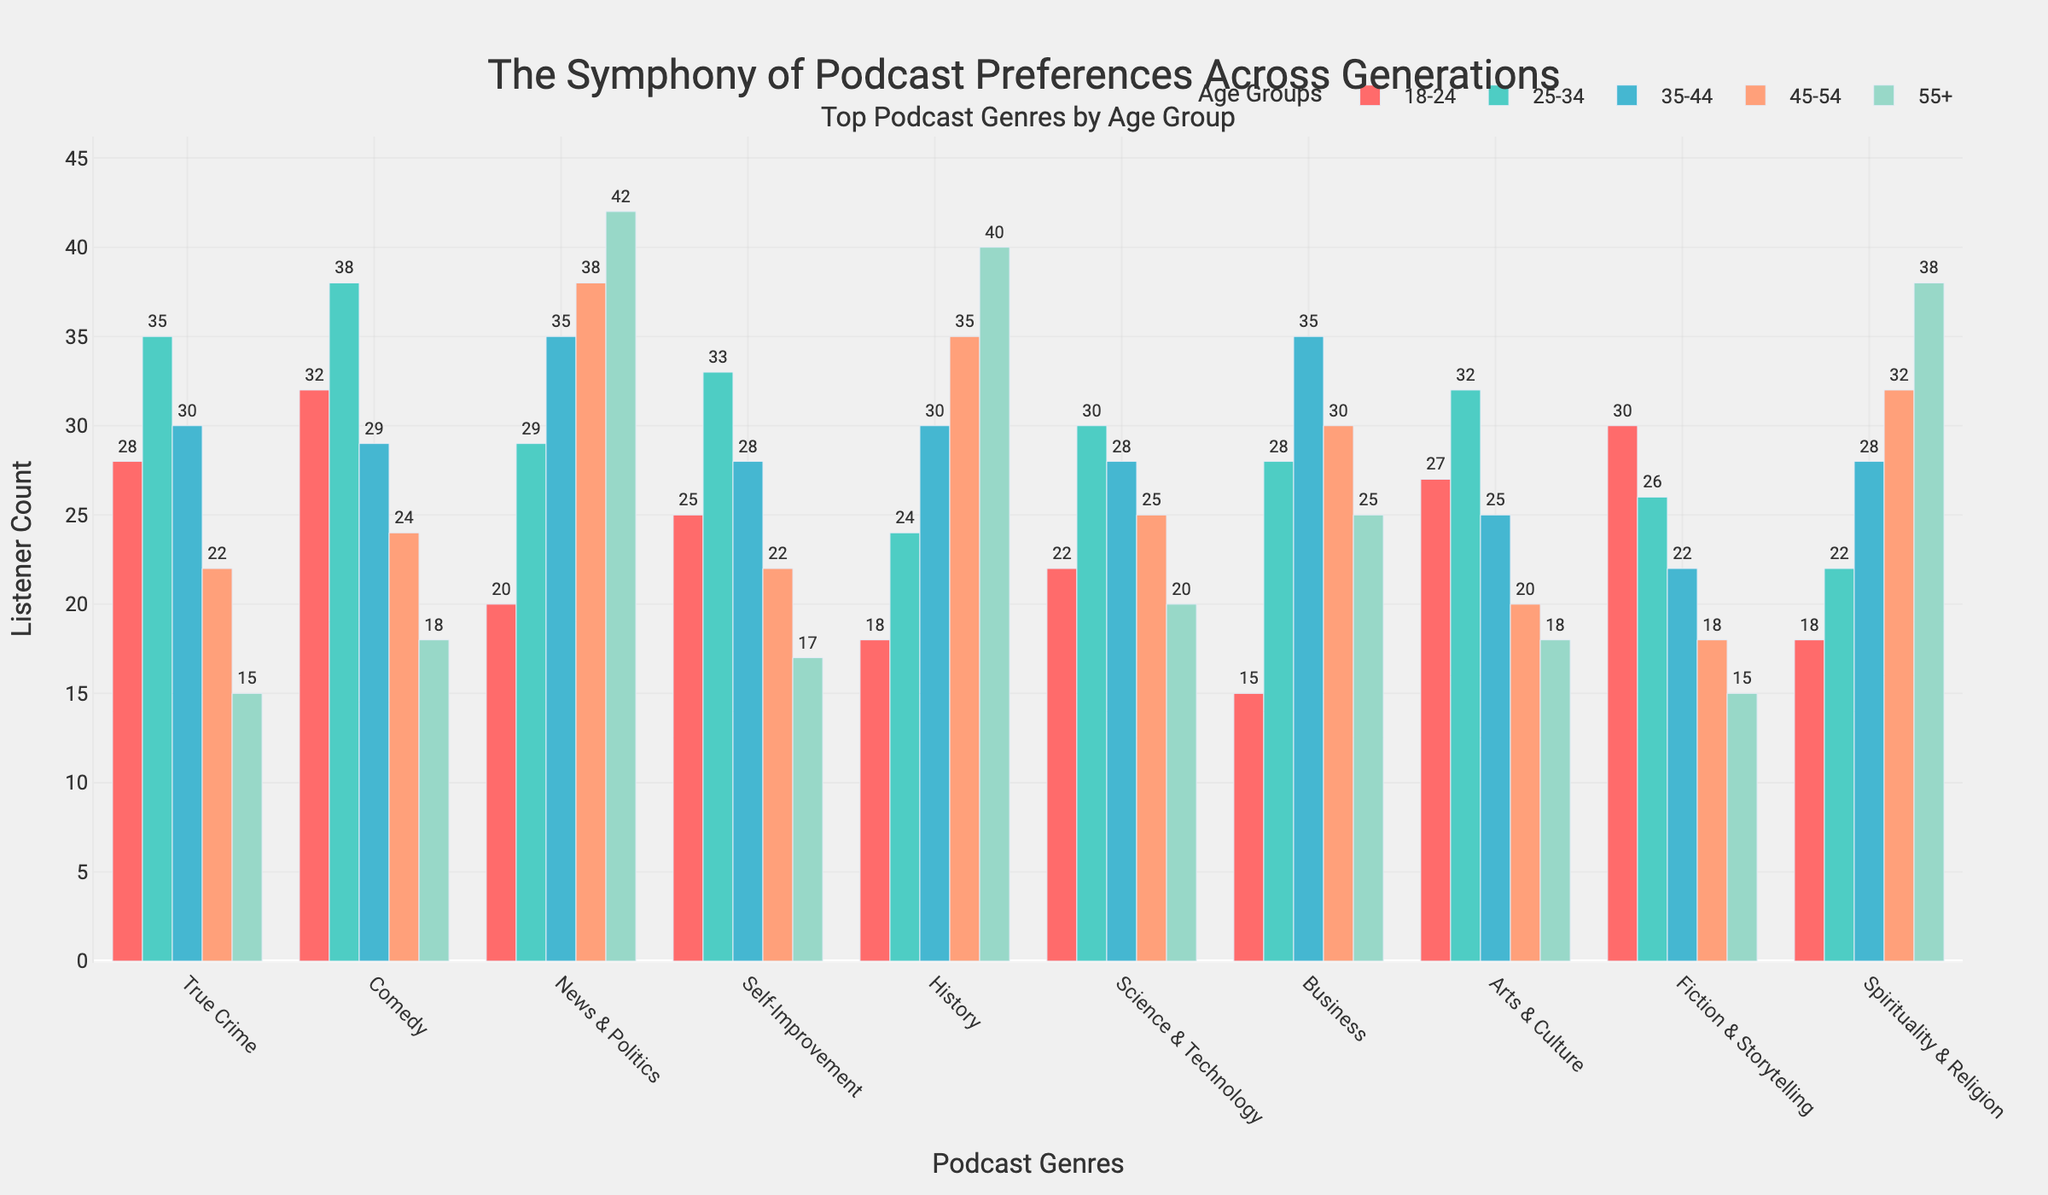What's the most popular genre among the 18-24 age group? From the figure, the Comedy genre has the tallest bar in the 18-24 age group, indicating the highest listener count.
Answer: Comedy Which genre shows a steady increase in listener count with age? The bars for News & Politics and History increase progressively as the age groups go from 18-24 to 55+. This indicates a steady increase in listener count with age.
Answer: News & Politics, History What is the difference in listener count for True Crime between the 25-34 and 55+ age groups? The listener count for True Crime is 35 in the 25-34 age group and 15 in the 55+ age group. The difference is 35 - 15.
Answer: 20 What proportion of listeners aged 25-34 prefer Business podcasts compared to Comedy? For the 25-34 age group, Business has 28 listeners and Comedy has 38 listeners. The proportion is 28/38.
Answer: 0.74 Which genre has the least listeners aged 45-54, and how many? The genre with the shortest bar in the 45-54 age group is Fiction & Storytelling, indicating the lowest listener count.
Answer: Fiction & Storytelling, 18 How does the listener count for Comedy in the 25-34 age group compare to Science & Technology in the same group? The Comedy genre has 38 listeners in the 25-34 age group, while Science & Technology has 30 listeners in the same group. Comedy has 8 more listeners than Science & Technology.
Answer: Comedy has 8 more listeners Which age group shows the highest listener count for Spirituality & Religion? The age group 55+ has the tallest bar in the Spirituality & Religion genre, indicating the highest listener count.
Answer: 55+ What is the average listener count for the News & Politics genre across all age groups? The listener counts for News & Politics across the age groups are 20, 29, 35, 38, 42. The average is (20+29+35+38+42)/5.
Answer: 32.8 Which genre is more popular in the 35-44 age group, Self-Improvement or Arts & Culture? The bar for Self-Improvement in the 35-44 age group is higher than Arts & Culture, indicating more listeners.
Answer: Self-Improvement 